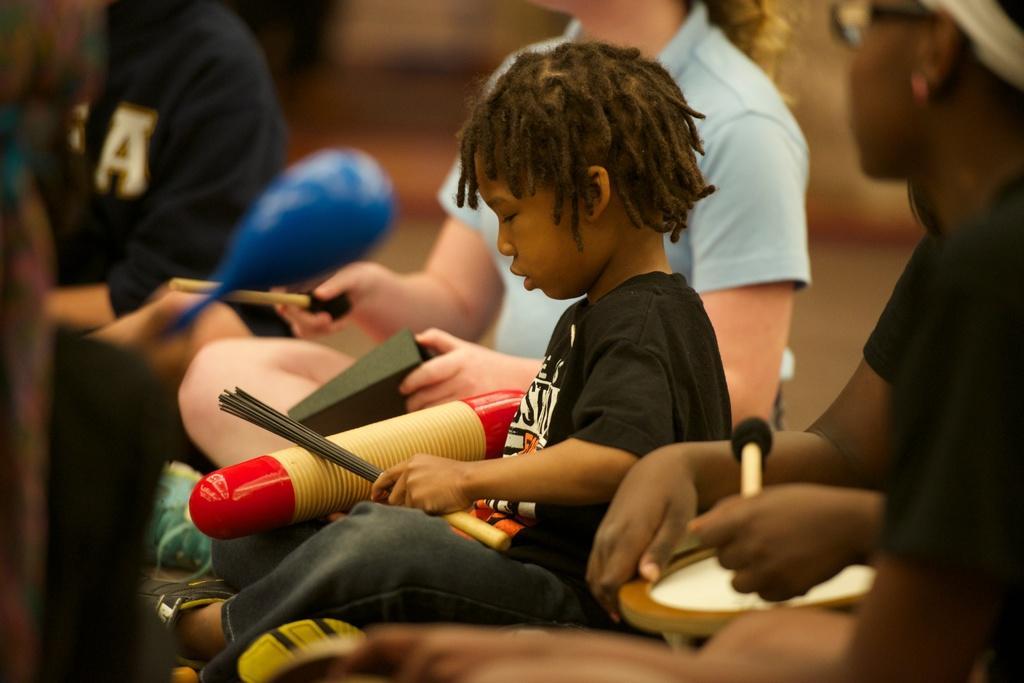Could you give a brief overview of what you see in this image? In this image I can see group of people sitting. The person in front wearing black shirt, gray pant and holding some object which is in red and cream color. 